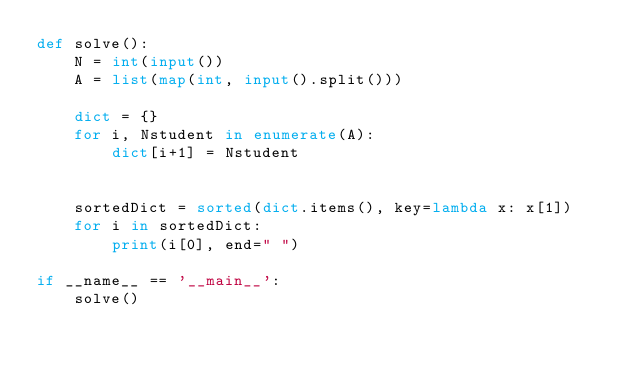Convert code to text. <code><loc_0><loc_0><loc_500><loc_500><_Python_>def solve():
    N = int(input())
    A = list(map(int, input().split()))

    dict = {}
    for i, Nstudent in enumerate(A):
        dict[i+1] = Nstudent
    

    sortedDict = sorted(dict.items(), key=lambda x: x[1])
    for i in sortedDict:
        print(i[0], end=" ")

if __name__ == '__main__':
    solve()
</code> 